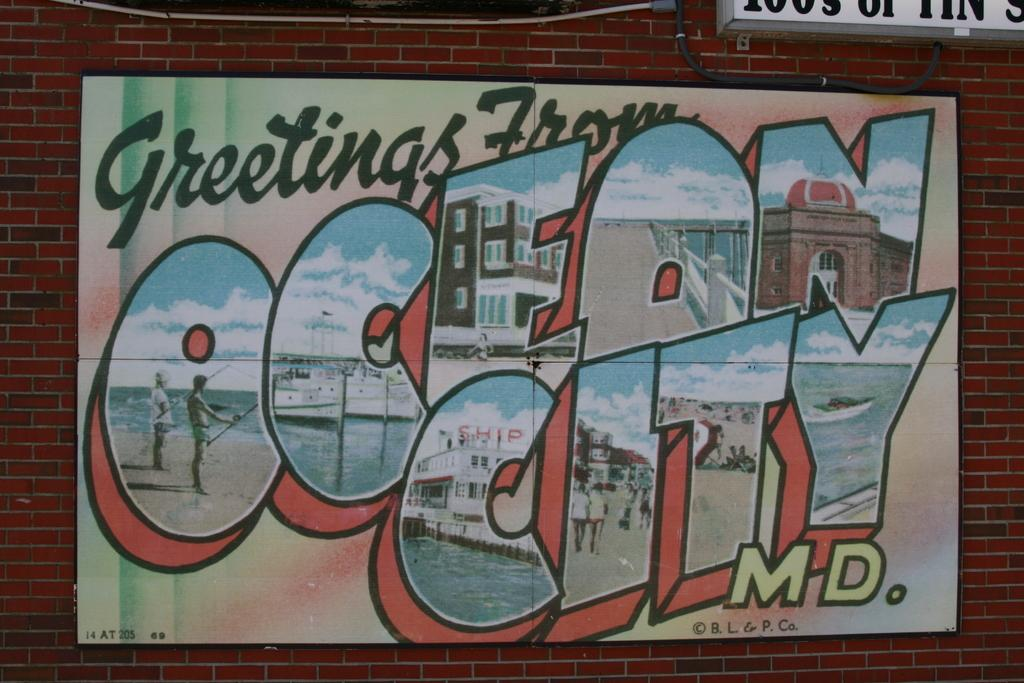<image>
Write a terse but informative summary of the picture. Drawing outdoors on a brick wall of Ocean City. 